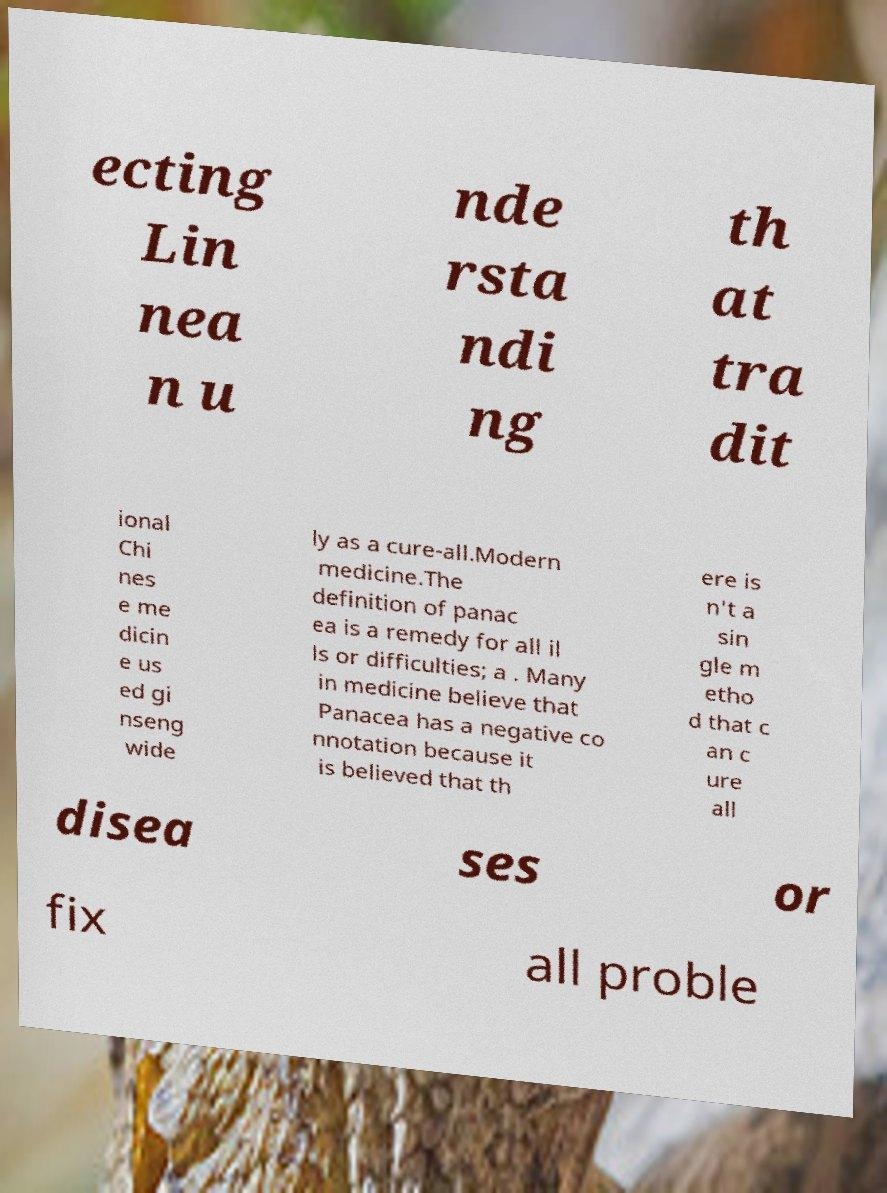Could you assist in decoding the text presented in this image and type it out clearly? ecting Lin nea n u nde rsta ndi ng th at tra dit ional Chi nes e me dicin e us ed gi nseng wide ly as a cure-all.Modern medicine.The definition of panac ea is a remedy for all il ls or difficulties; a . Many in medicine believe that Panacea has a negative co nnotation because it is believed that th ere is n't a sin gle m etho d that c an c ure all disea ses or fix all proble 